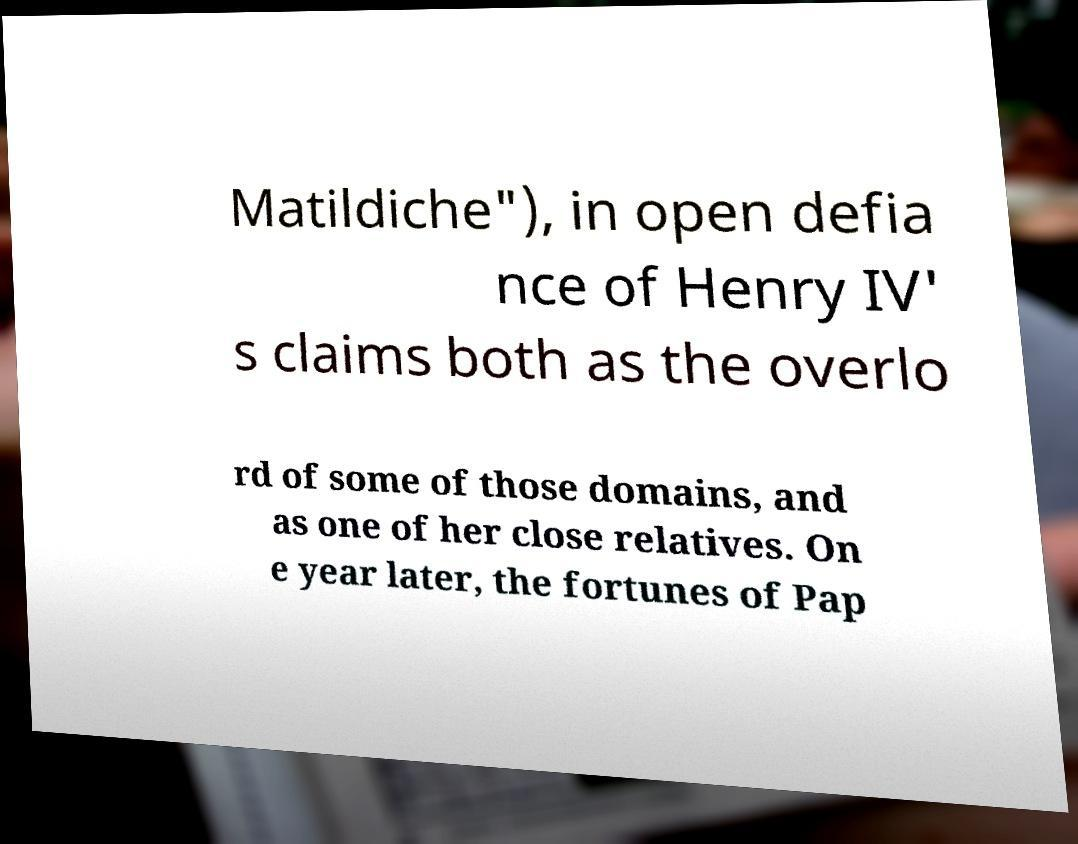Could you assist in decoding the text presented in this image and type it out clearly? Matildiche"), in open defia nce of Henry IV' s claims both as the overlo rd of some of those domains, and as one of her close relatives. On e year later, the fortunes of Pap 